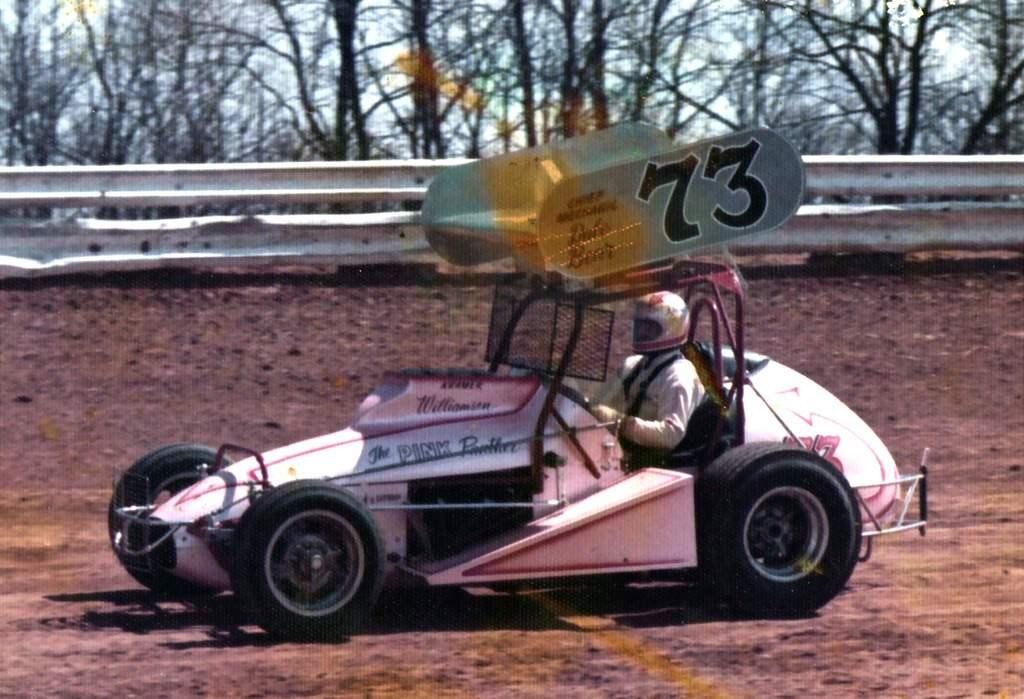<image>
Give a short and clear explanation of the subsequent image. A race car called there Pink Panther races along a dirty track. 